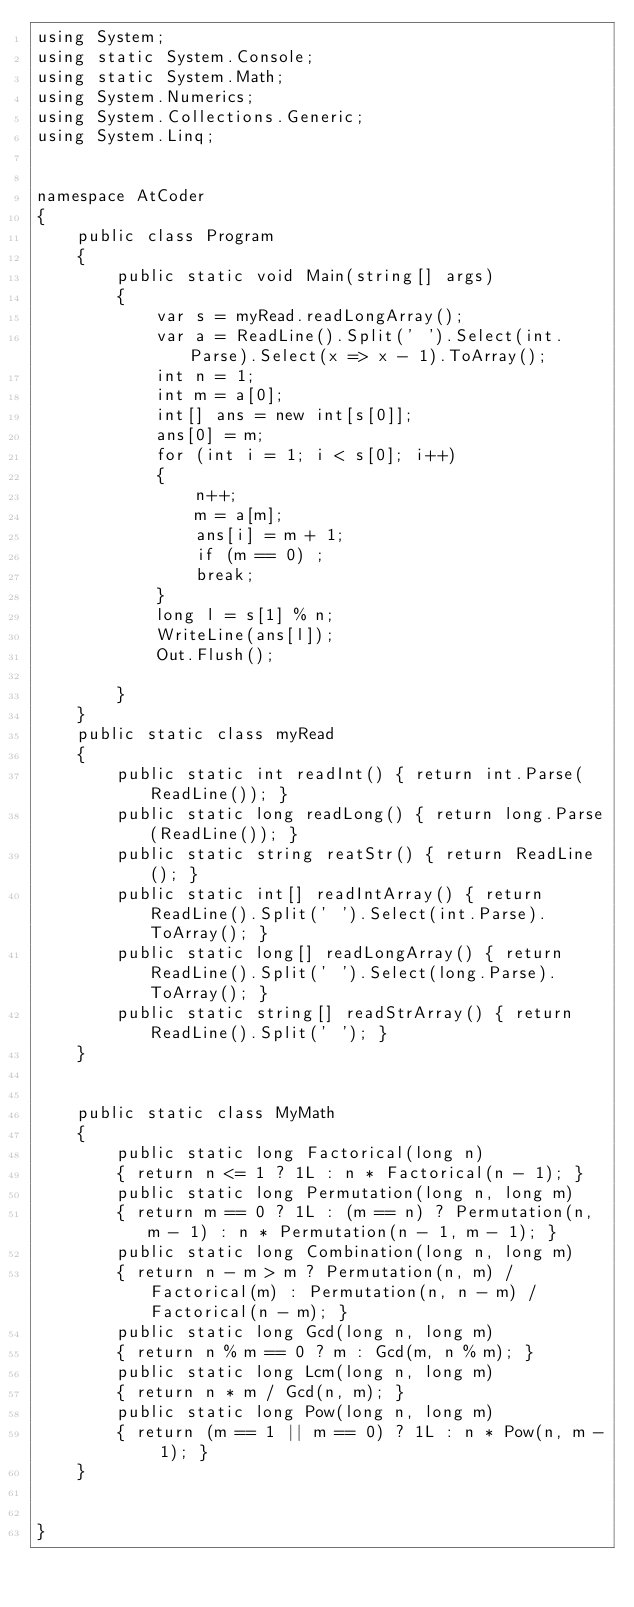Convert code to text. <code><loc_0><loc_0><loc_500><loc_500><_C#_>using System;
using static System.Console;
using static System.Math;
using System.Numerics;
using System.Collections.Generic;
using System.Linq;


namespace AtCoder
{
    public class Program
    {
        public static void Main(string[] args)
        {
            var s = myRead.readLongArray();
            var a = ReadLine().Split(' ').Select(int.Parse).Select(x => x - 1).ToArray();
            int n = 1;
            int m = a[0];
            int[] ans = new int[s[0]];
            ans[0] = m;
            for (int i = 1; i < s[0]; i++)
            {
                n++;
                m = a[m];
                ans[i] = m + 1;
                if (m == 0) ;
                break;
            }
            long l = s[1] % n;
            WriteLine(ans[l]);
            Out.Flush();

        }
    }
    public static class myRead
    {
        public static int readInt() { return int.Parse(ReadLine()); }
        public static long readLong() { return long.Parse(ReadLine()); }
        public static string reatStr() { return ReadLine(); }
        public static int[] readIntArray() { return ReadLine().Split(' ').Select(int.Parse).ToArray(); }
        public static long[] readLongArray() { return ReadLine().Split(' ').Select(long.Parse).ToArray(); }
        public static string[] readStrArray() { return ReadLine().Split(' '); }
    }


    public static class MyMath
    {
        public static long Factorical(long n)
        { return n <= 1 ? 1L : n * Factorical(n - 1); }
        public static long Permutation(long n, long m)
        { return m == 0 ? 1L : (m == n) ? Permutation(n, m - 1) : n * Permutation(n - 1, m - 1); }
        public static long Combination(long n, long m)
        { return n - m > m ? Permutation(n, m) / Factorical(m) : Permutation(n, n - m) / Factorical(n - m); }
        public static long Gcd(long n, long m)
        { return n % m == 0 ? m : Gcd(m, n % m); }
        public static long Lcm(long n, long m)
        { return n * m / Gcd(n, m); }
        public static long Pow(long n, long m)
        { return (m == 1 || m == 0) ? 1L : n * Pow(n, m - 1); }
    }


}</code> 